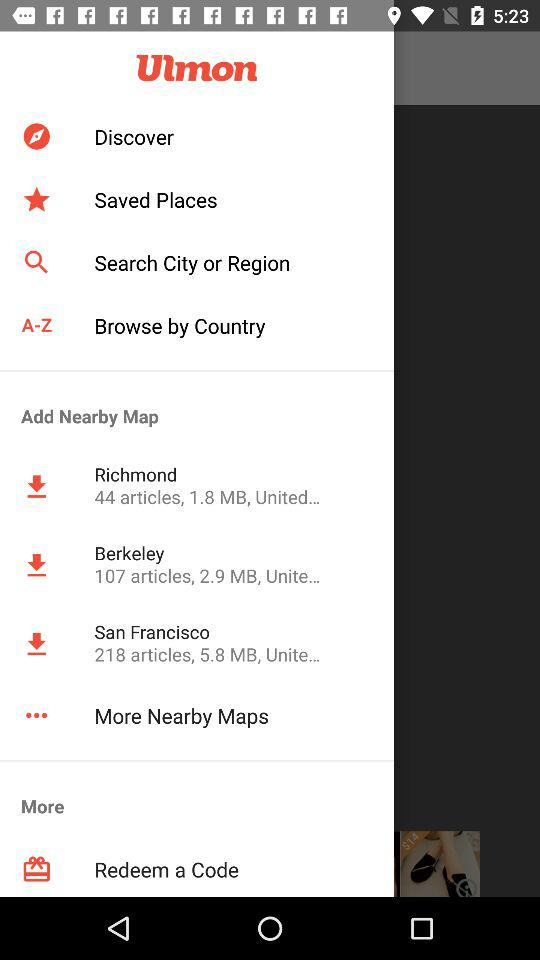What is the application's name? The application's name is "Ulmon". 